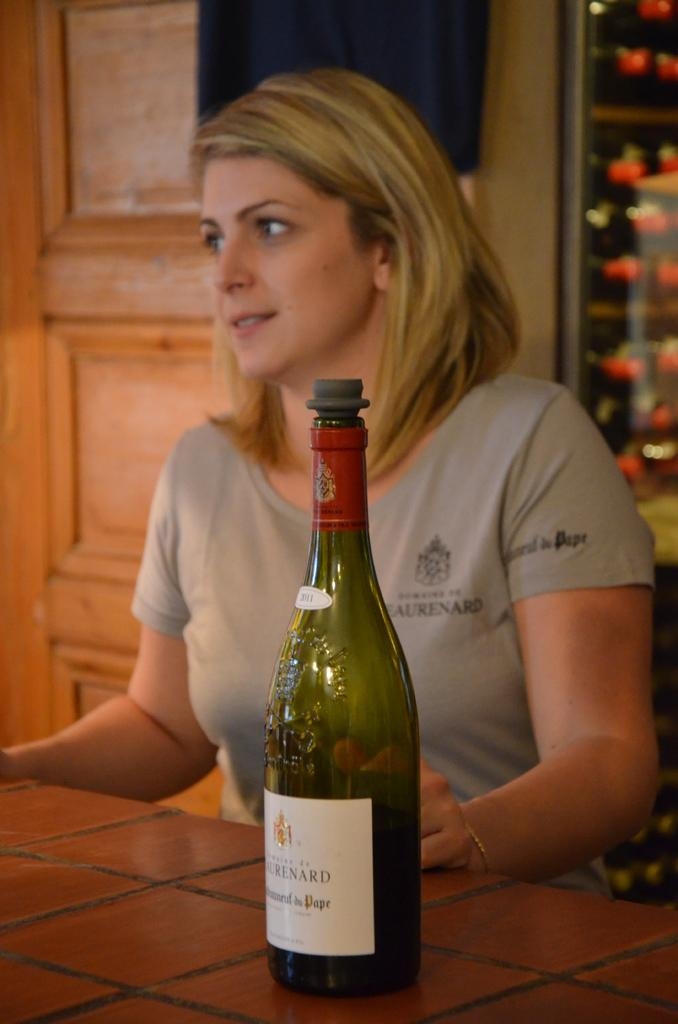What piece of furniture is present in the image? There is a table in the image. What object is placed on the table? There is a bottle on the table. Who is sitting beside the bottle? There is a woman sitting beside the bottle. What is the woman wearing? The woman is wearing a grey t-shirt. What type of structure can be seen in the image? There is a wall and a door in the image. Can you tell me how many slaves are depicted in the image? There are no slaves present in the image. What type of card is being played by the woman in the image? There is no card game or card present in the image. 